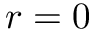<formula> <loc_0><loc_0><loc_500><loc_500>r = 0</formula> 